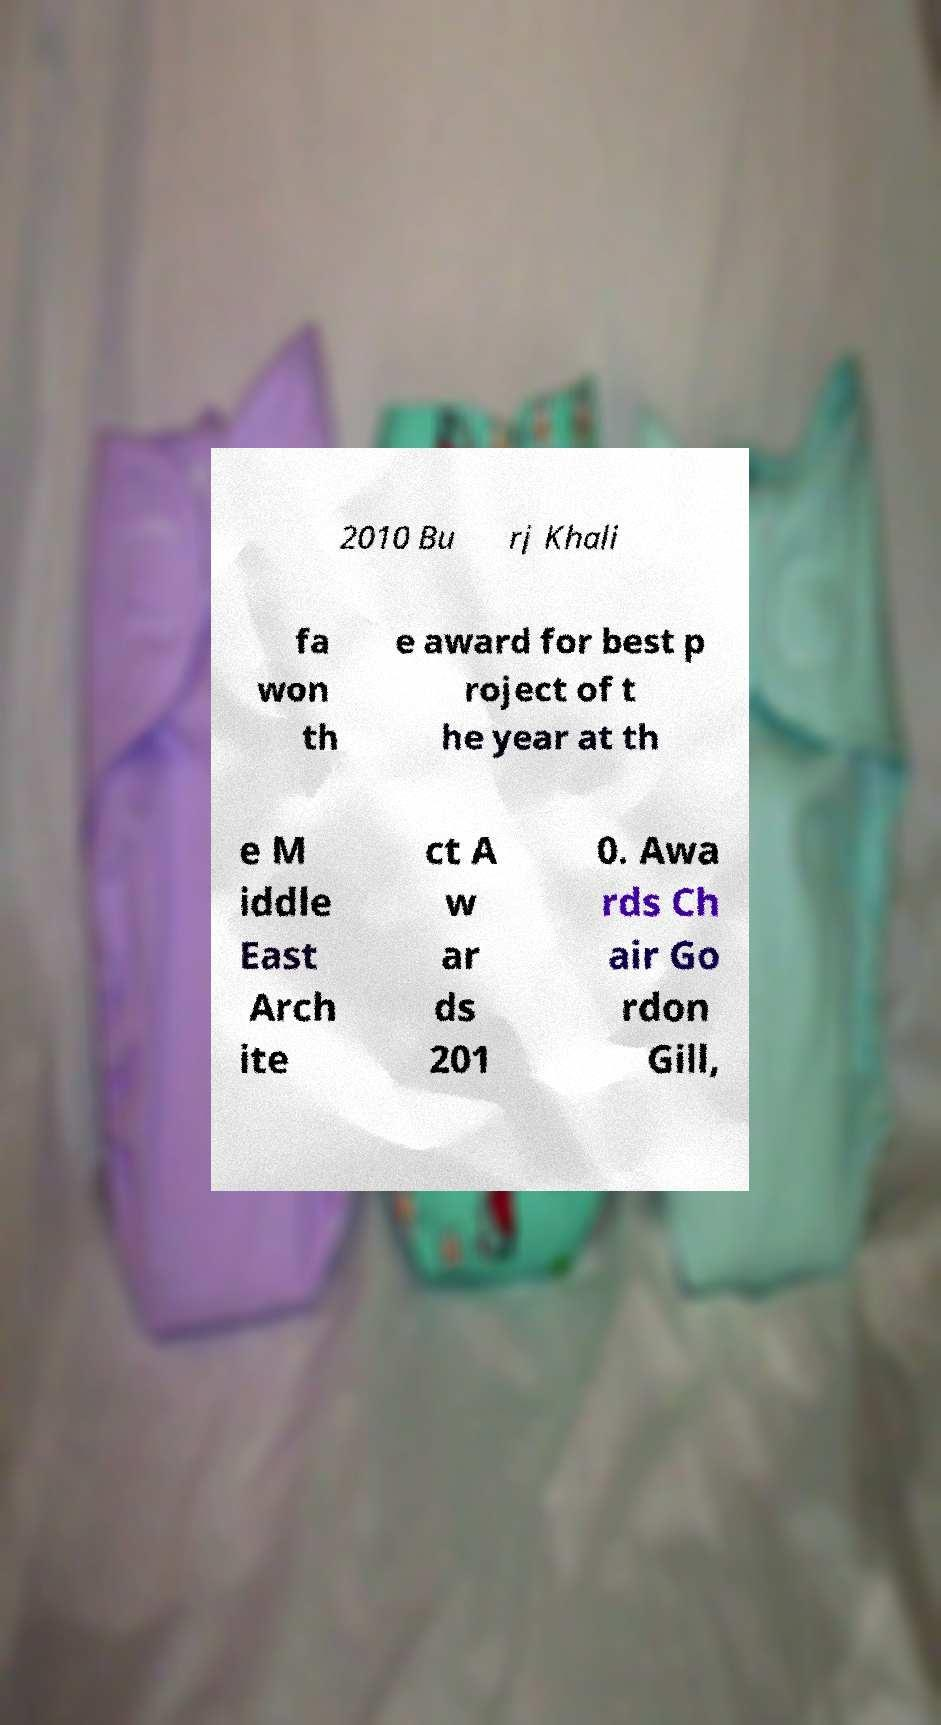There's text embedded in this image that I need extracted. Can you transcribe it verbatim? 2010 Bu rj Khali fa won th e award for best p roject of t he year at th e M iddle East Arch ite ct A w ar ds 201 0. Awa rds Ch air Go rdon Gill, 